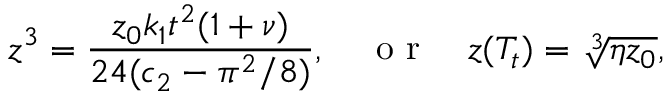Convert formula to latex. <formula><loc_0><loc_0><loc_500><loc_500>z ^ { 3 } = \frac { z _ { 0 } k _ { 1 } t ^ { 2 } ( 1 + \nu ) } { 2 4 ( c _ { 2 } - \pi ^ { 2 } / 8 ) } , \quad o r \quad z ( T _ { t } ) = \sqrt { [ } 3 ] { \eta z _ { 0 } } ,</formula> 